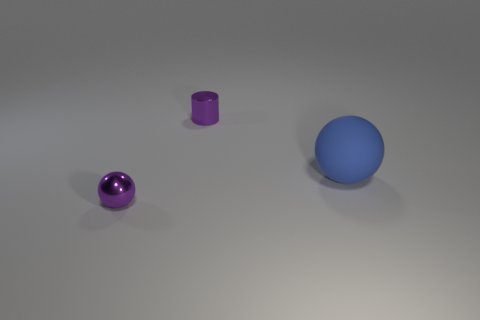What kind of material do the objects seem to be made of, and how might that affect their real-world use? The small purple sphere appears to be made of a polished, reflective material, resembling glass or polished metal. The cylinder also has a metallic finish, suggesting it is made of metal. Lastly, the blue sphere has a matte finish, which might indicate a plastic or rubber composition. The reflective or metallic materials could be used where durability and aesthetics are important, while the plastic or rubber-like material of the blue sphere might suggest its use in situations where less weight and more flexibility are needed. 